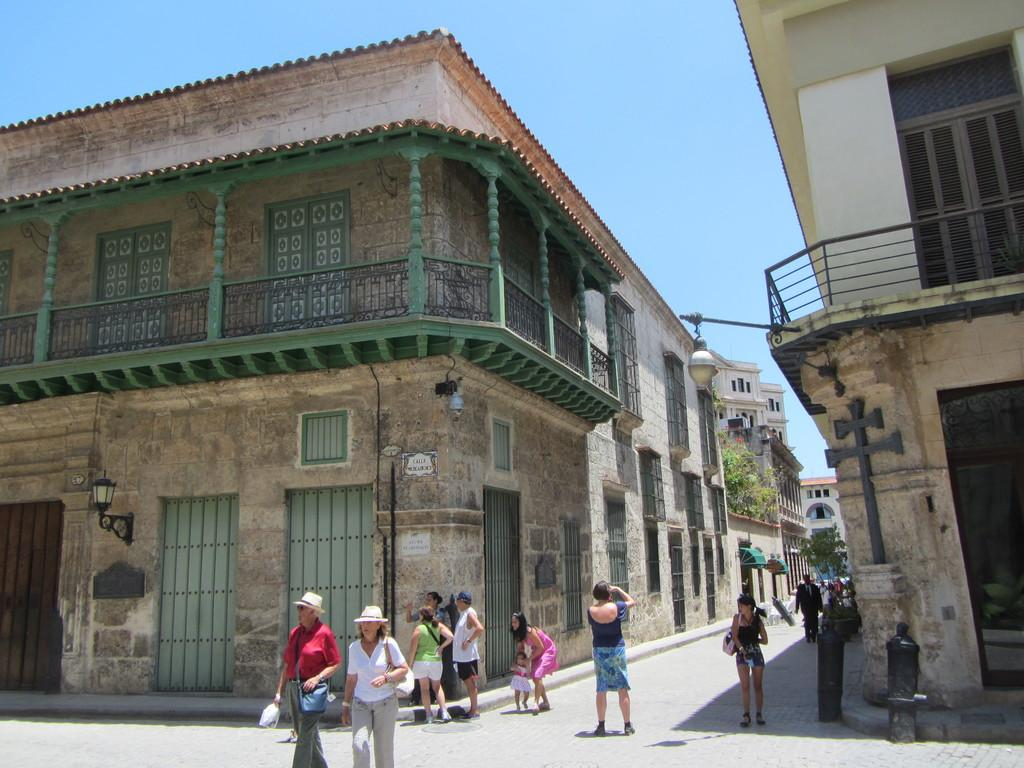Who or what can be seen in the image? There are people in the image. What type of structures are visible in the image? There are buildings in the image. What type of vegetation is present in the image? There are trees in the image. What can be seen beneath the people and buildings? The ground is visible in the image. What objects are on the ground in the image? There are objects on the ground in the image. What is visible above the people and buildings? The sky is visible in the image. What type of fruit can be seen growing on the canvas in the image? There is no canvas or fruit present in the image. 